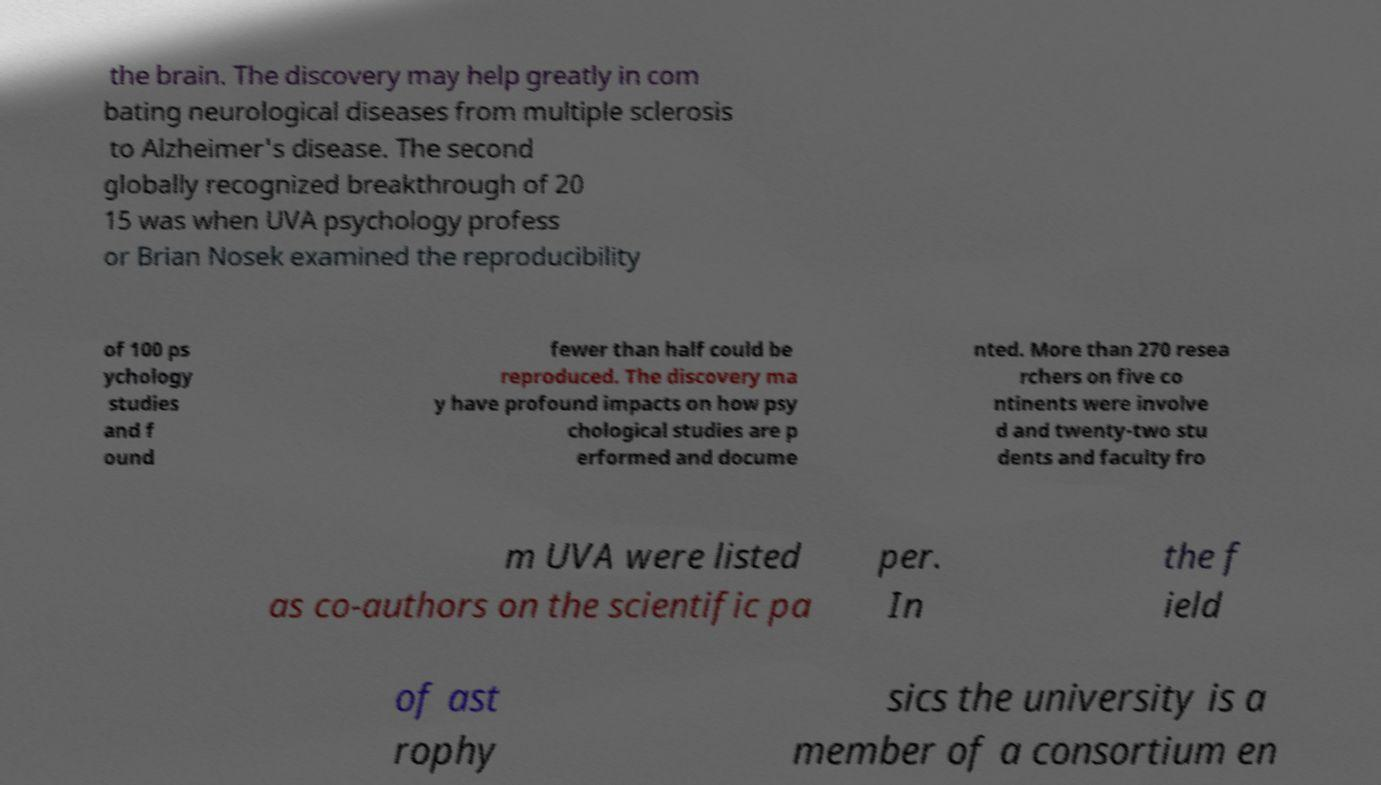Could you assist in decoding the text presented in this image and type it out clearly? the brain. The discovery may help greatly in com bating neurological diseases from multiple sclerosis to Alzheimer's disease. The second globally recognized breakthrough of 20 15 was when UVA psychology profess or Brian Nosek examined the reproducibility of 100 ps ychology studies and f ound fewer than half could be reproduced. The discovery ma y have profound impacts on how psy chological studies are p erformed and docume nted. More than 270 resea rchers on five co ntinents were involve d and twenty-two stu dents and faculty fro m UVA were listed as co-authors on the scientific pa per. In the f ield of ast rophy sics the university is a member of a consortium en 